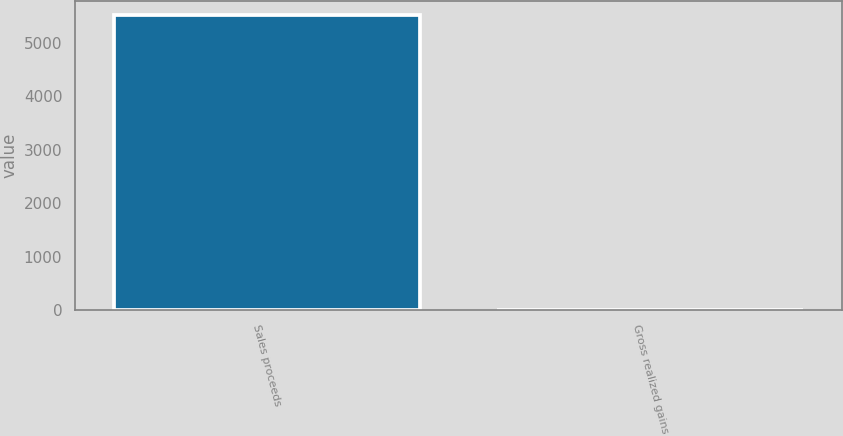<chart> <loc_0><loc_0><loc_500><loc_500><bar_chart><fcel>Sales proceeds<fcel>Gross realized gains<nl><fcel>5512<fcel>1<nl></chart> 